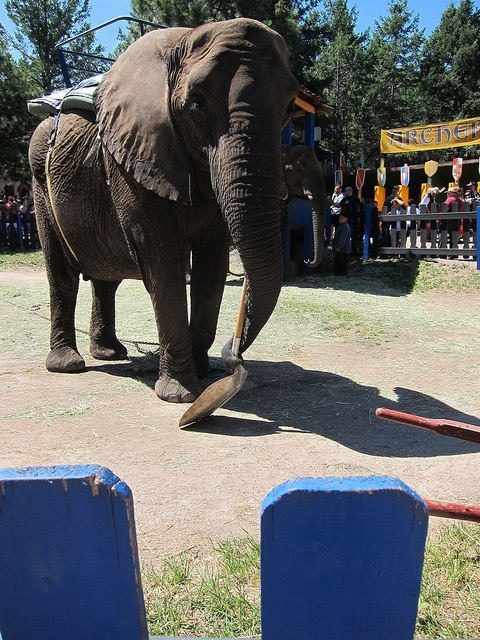Describe the objects in this image and their specific colors. I can see elephant in lightblue, black, gray, darkgray, and beige tones, elephant in lightblue, black, gray, and darkgray tones, people in lightblue, black, and gray tones, people in lightblue, black, maroon, navy, and darkblue tones, and people in lightblue, black, maroon, and brown tones in this image. 